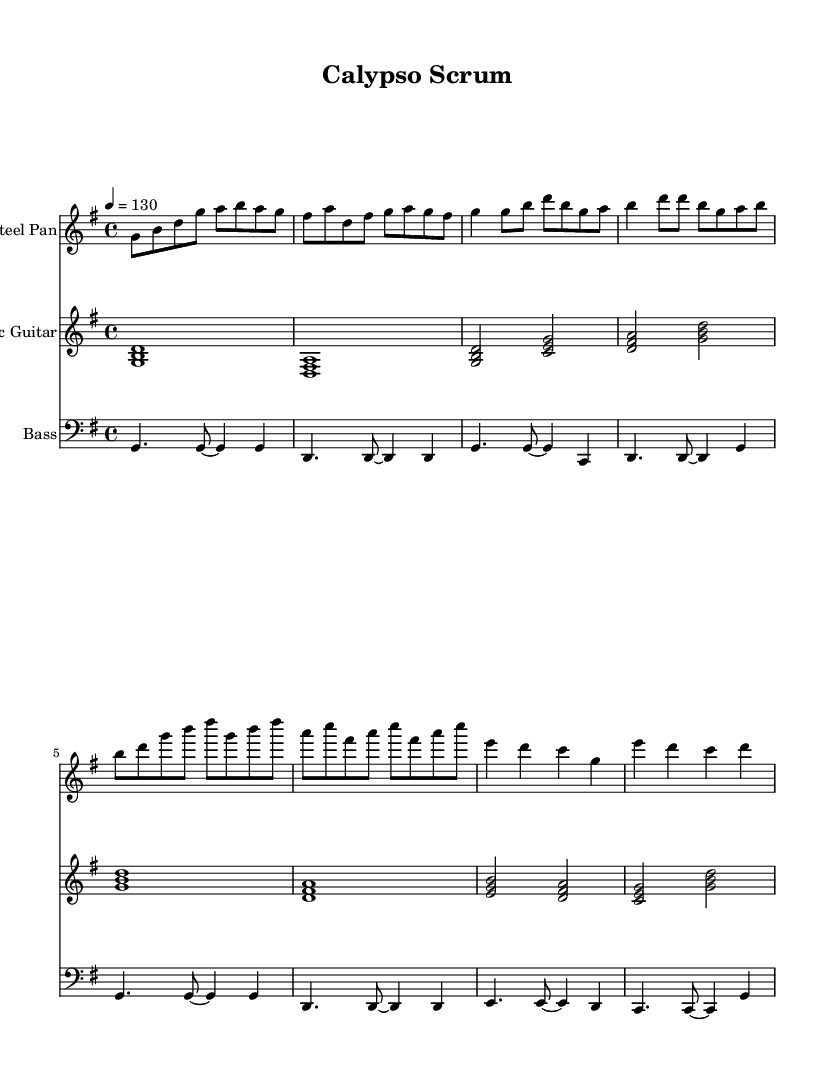What is the key signature of this music? The key signature is indicated by the sharp symbols on the staff, and it consists of one sharp (F#). This corresponds to the key of G major, which is a common key for lively and upbeat music like Soca and Latin fusion.
Answer: G major What is the time signature of this music? The time signature is displayed at the beginning of the piece with a "4/4" notation. This means there are four beats in each measure, and each quarter note is one beat. This is a typical time signature for Soca-influenced music, encouraging dance and movement.
Answer: 4/4 What is the tempo marking for this piece? The tempo is indicated as "4 = 130" and is commonly placed above the staff. This means there are 130 beats per minute, which is a brisk tempo suitable for pre-game warm-ups to energize the players.
Answer: 130 How many measures are in the Steel Pan part? Counting the notation for the Steel Pan, we see that there are a total of 8 measures present in the score. Each measure corresponds to the way the music is structured, typically influencing the energy level during warm-ups.
Answer: 8 What is the main instrument used in this sheet music? The main instrument is labeled clearly at the beginning of the respective staff lines. The first staff indicates "Steel Pan," which is distinctive in Soca music for its bright and resonant tones that energize the atmosphere.
Answer: Steel Pan Which instrument plays chords primarily in this piece? The instrument labeled "Electric Guitar" is responsible for playing harmonized chords throughout the piece. Chordal accompaniment is vital in Latin and Soca music to create a fuller sound and maintain rhythm, distinguishing it from melodic lines.
Answer: Electric Guitar What is the overall style represented in this music? The music combines elements of Calypso and Latin rhythms, characterized by syncopation, vibrant melodies, and a festive spirit. This fusion creates a unique atmosphere suitable for sport and celebration.
Answer: Soca-influenced Latin fusion 